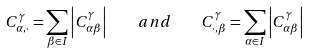Convert formula to latex. <formula><loc_0><loc_0><loc_500><loc_500>C ^ { \gamma } _ { \alpha , \cdot } = \sum _ { \beta \in I } \left | C ^ { \gamma } _ { \alpha \beta } \right | \quad a n d \quad C ^ { \gamma } _ { \cdot , \beta } = \sum _ { \alpha \in I } \left | C ^ { \gamma } _ { \alpha \beta } \right |</formula> 